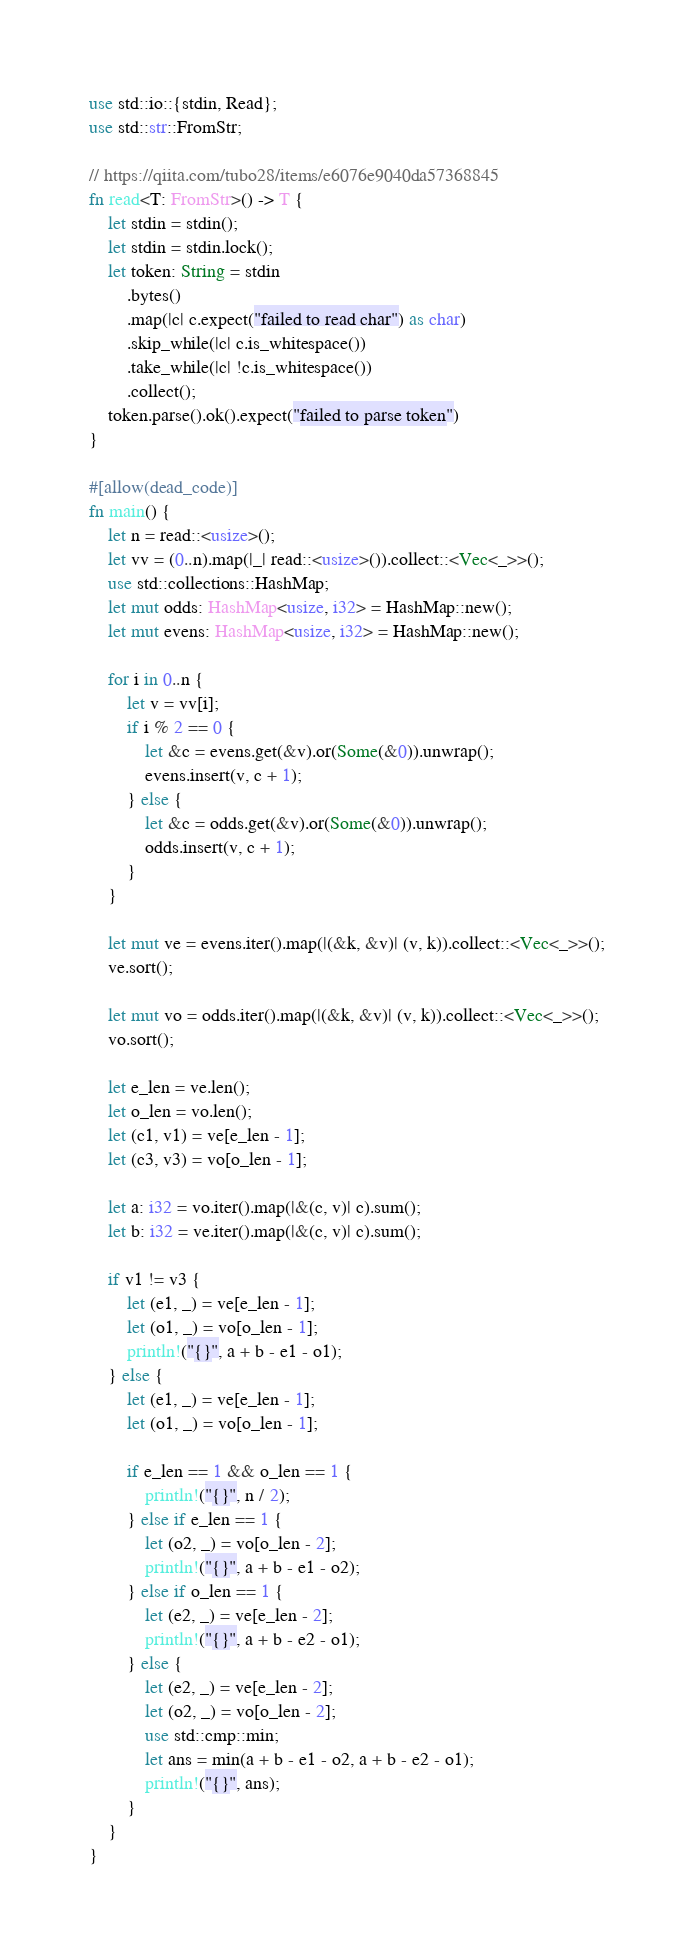Convert code to text. <code><loc_0><loc_0><loc_500><loc_500><_Rust_>use std::io::{stdin, Read};
use std::str::FromStr;

// https://qiita.com/tubo28/items/e6076e9040da57368845
fn read<T: FromStr>() -> T {
    let stdin = stdin();
    let stdin = stdin.lock();
    let token: String = stdin
        .bytes()
        .map(|c| c.expect("failed to read char") as char)
        .skip_while(|c| c.is_whitespace())
        .take_while(|c| !c.is_whitespace())
        .collect();
    token.parse().ok().expect("failed to parse token")
}

#[allow(dead_code)]
fn main() {
    let n = read::<usize>();
    let vv = (0..n).map(|_| read::<usize>()).collect::<Vec<_>>();
    use std::collections::HashMap;
    let mut odds: HashMap<usize, i32> = HashMap::new();
    let mut evens: HashMap<usize, i32> = HashMap::new();

    for i in 0..n {
        let v = vv[i];
        if i % 2 == 0 {
            let &c = evens.get(&v).or(Some(&0)).unwrap();
            evens.insert(v, c + 1);
        } else {
            let &c = odds.get(&v).or(Some(&0)).unwrap();
            odds.insert(v, c + 1);
        }
    }

    let mut ve = evens.iter().map(|(&k, &v)| (v, k)).collect::<Vec<_>>();
    ve.sort();

    let mut vo = odds.iter().map(|(&k, &v)| (v, k)).collect::<Vec<_>>();
    vo.sort();

    let e_len = ve.len();
    let o_len = vo.len();
    let (c1, v1) = ve[e_len - 1];
    let (c3, v3) = vo[o_len - 1];

    let a: i32 = vo.iter().map(|&(c, v)| c).sum();
    let b: i32 = ve.iter().map(|&(c, v)| c).sum();

    if v1 != v3 {
        let (e1, _) = ve[e_len - 1];
        let (o1, _) = vo[o_len - 1];
        println!("{}", a + b - e1 - o1);
    } else {
        let (e1, _) = ve[e_len - 1];
        let (o1, _) = vo[o_len - 1];

        if e_len == 1 && o_len == 1 {
            println!("{}", n / 2);
        } else if e_len == 1 {
            let (o2, _) = vo[o_len - 2];
            println!("{}", a + b - e1 - o2);
        } else if o_len == 1 {
            let (e2, _) = ve[e_len - 2];
            println!("{}", a + b - e2 - o1);
        } else {
            let (e2, _) = ve[e_len - 2];
            let (o2, _) = vo[o_len - 2];
            use std::cmp::min;
            let ans = min(a + b - e1 - o2, a + b - e2 - o1);
            println!("{}", ans);
        }
    }
}
</code> 